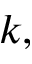Convert formula to latex. <formula><loc_0><loc_0><loc_500><loc_500>k ,</formula> 